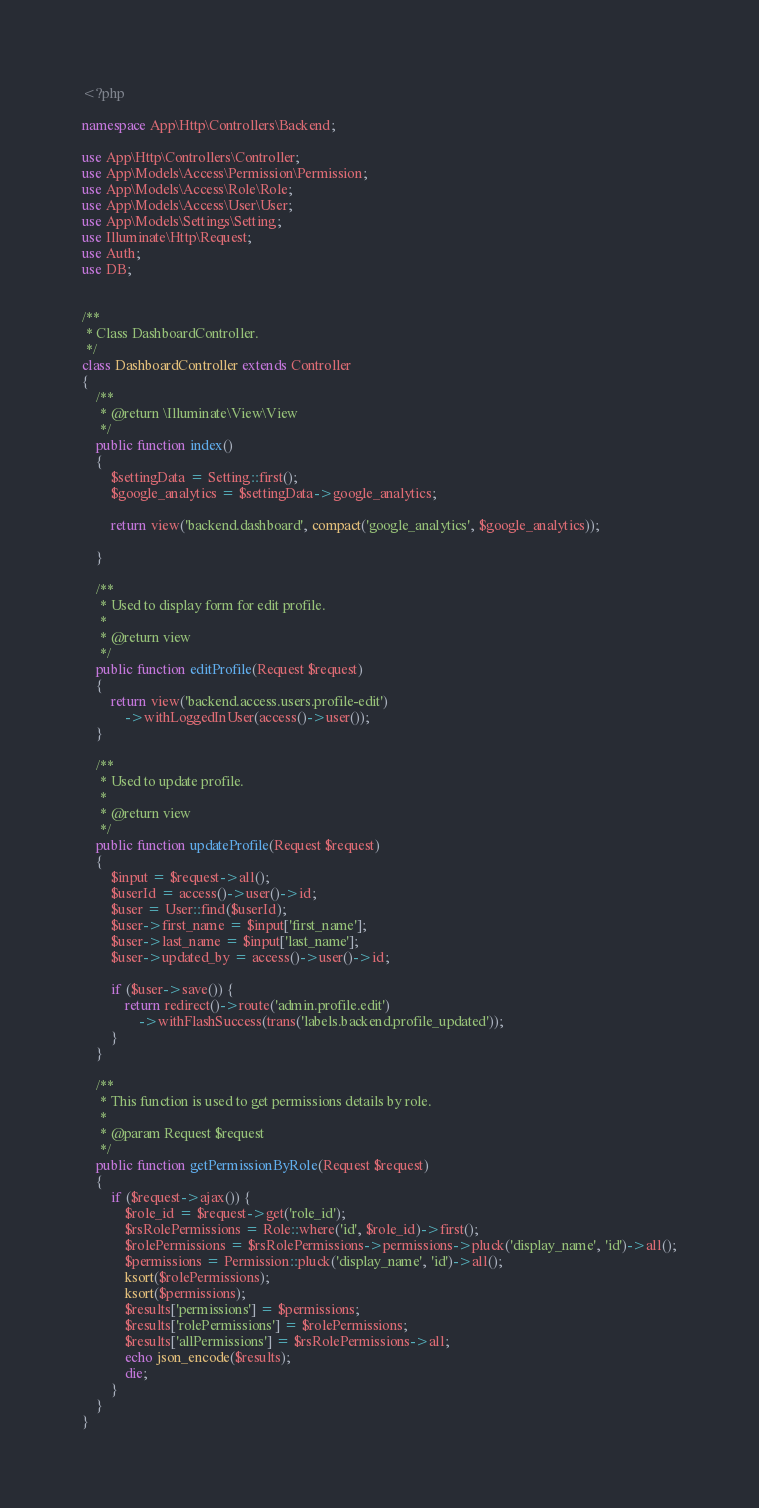<code> <loc_0><loc_0><loc_500><loc_500><_PHP_><?php

namespace App\Http\Controllers\Backend;

use App\Http\Controllers\Controller;
use App\Models\Access\Permission\Permission;
use App\Models\Access\Role\Role;
use App\Models\Access\User\User;
use App\Models\Settings\Setting;
use Illuminate\Http\Request;
use Auth;
use DB;


/**
 * Class DashboardController.
 */
class DashboardController extends Controller
{
    /**
     * @return \Illuminate\View\View
     */
    public function index()
    {
        $settingData = Setting::first();
        $google_analytics = $settingData->google_analytics;

        return view('backend.dashboard', compact('google_analytics', $google_analytics));
       
    }

    /**
     * Used to display form for edit profile.
     *
     * @return view
     */
    public function editProfile(Request $request)
    {
        return view('backend.access.users.profile-edit')
            ->withLoggedInUser(access()->user());
    }

    /**
     * Used to update profile.
     *
     * @return view
     */
    public function updateProfile(Request $request)
    {
        $input = $request->all();
        $userId = access()->user()->id;
        $user = User::find($userId);
        $user->first_name = $input['first_name'];
        $user->last_name = $input['last_name'];
        $user->updated_by = access()->user()->id;

        if ($user->save()) {
            return redirect()->route('admin.profile.edit')
                ->withFlashSuccess(trans('labels.backend.profile_updated'));
        }
    }

    /**
     * This function is used to get permissions details by role.
     *
     * @param Request $request
     */
    public function getPermissionByRole(Request $request)
    {
        if ($request->ajax()) {
            $role_id = $request->get('role_id');
            $rsRolePermissions = Role::where('id', $role_id)->first();
            $rolePermissions = $rsRolePermissions->permissions->pluck('display_name', 'id')->all();
            $permissions = Permission::pluck('display_name', 'id')->all();
            ksort($rolePermissions);
            ksort($permissions);
            $results['permissions'] = $permissions;
            $results['rolePermissions'] = $rolePermissions;
            $results['allPermissions'] = $rsRolePermissions->all;
            echo json_encode($results);
            die;
        }
    }
}
</code> 